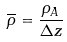Convert formula to latex. <formula><loc_0><loc_0><loc_500><loc_500>\overline { \rho } = \frac { \rho _ { A } } { \Delta z }</formula> 